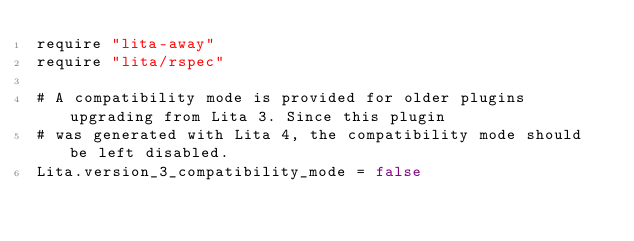Convert code to text. <code><loc_0><loc_0><loc_500><loc_500><_Ruby_>require "lita-away"
require "lita/rspec"

# A compatibility mode is provided for older plugins upgrading from Lita 3. Since this plugin
# was generated with Lita 4, the compatibility mode should be left disabled.
Lita.version_3_compatibility_mode = false
</code> 